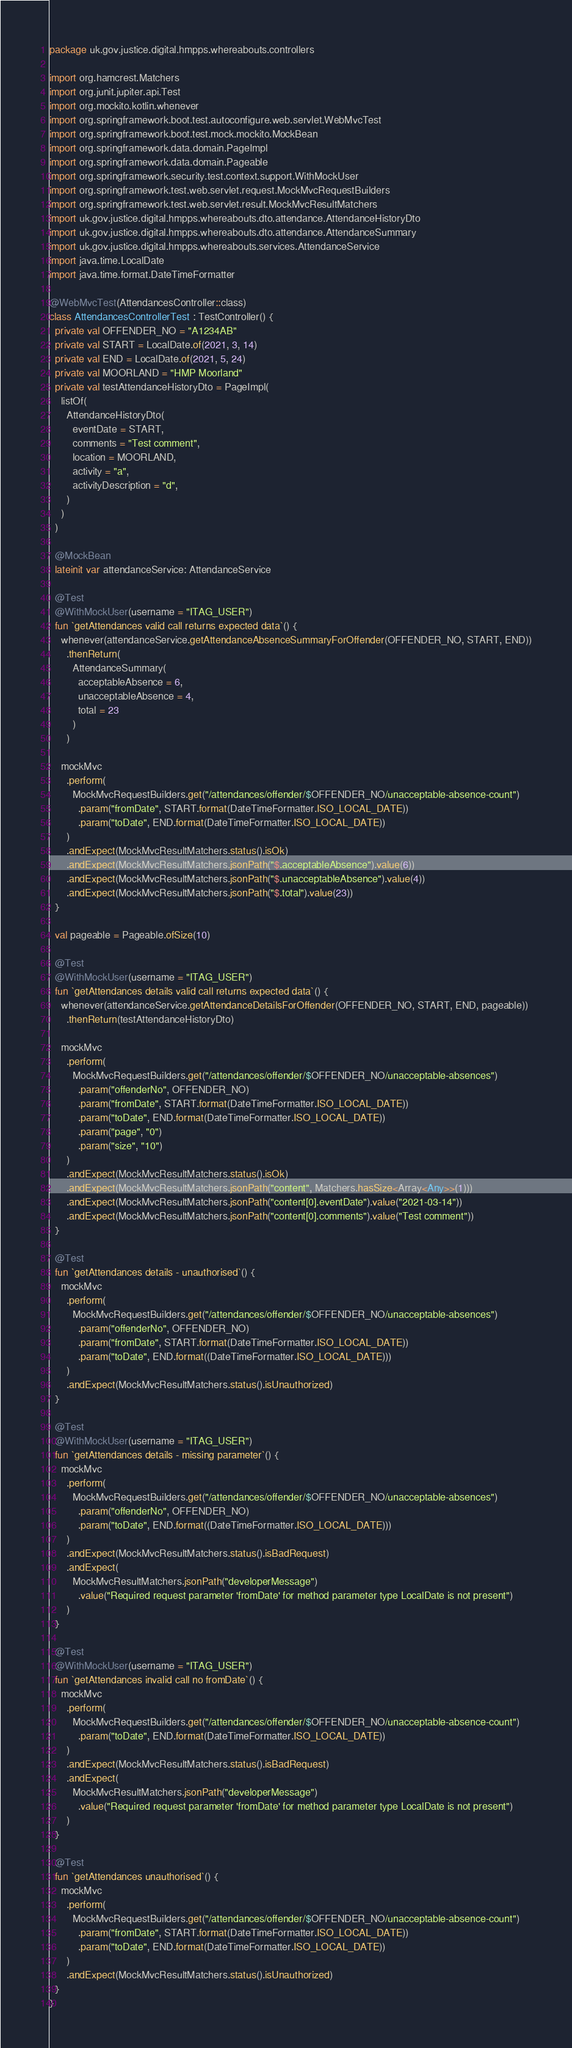<code> <loc_0><loc_0><loc_500><loc_500><_Kotlin_>package uk.gov.justice.digital.hmpps.whereabouts.controllers

import org.hamcrest.Matchers
import org.junit.jupiter.api.Test
import org.mockito.kotlin.whenever
import org.springframework.boot.test.autoconfigure.web.servlet.WebMvcTest
import org.springframework.boot.test.mock.mockito.MockBean
import org.springframework.data.domain.PageImpl
import org.springframework.data.domain.Pageable
import org.springframework.security.test.context.support.WithMockUser
import org.springframework.test.web.servlet.request.MockMvcRequestBuilders
import org.springframework.test.web.servlet.result.MockMvcResultMatchers
import uk.gov.justice.digital.hmpps.whereabouts.dto.attendance.AttendanceHistoryDto
import uk.gov.justice.digital.hmpps.whereabouts.dto.attendance.AttendanceSummary
import uk.gov.justice.digital.hmpps.whereabouts.services.AttendanceService
import java.time.LocalDate
import java.time.format.DateTimeFormatter

@WebMvcTest(AttendancesController::class)
class AttendancesControllerTest : TestController() {
  private val OFFENDER_NO = "A1234AB"
  private val START = LocalDate.of(2021, 3, 14)
  private val END = LocalDate.of(2021, 5, 24)
  private val MOORLAND = "HMP Moorland"
  private val testAttendanceHistoryDto = PageImpl(
    listOf(
      AttendanceHistoryDto(
        eventDate = START,
        comments = "Test comment",
        location = MOORLAND,
        activity = "a",
        activityDescription = "d",
      )
    )
  )

  @MockBean
  lateinit var attendanceService: AttendanceService

  @Test
  @WithMockUser(username = "ITAG_USER")
  fun `getAttendances valid call returns expected data`() {
    whenever(attendanceService.getAttendanceAbsenceSummaryForOffender(OFFENDER_NO, START, END))
      .thenReturn(
        AttendanceSummary(
          acceptableAbsence = 6,
          unacceptableAbsence = 4,
          total = 23
        )
      )

    mockMvc
      .perform(
        MockMvcRequestBuilders.get("/attendances/offender/$OFFENDER_NO/unacceptable-absence-count")
          .param("fromDate", START.format(DateTimeFormatter.ISO_LOCAL_DATE))
          .param("toDate", END.format(DateTimeFormatter.ISO_LOCAL_DATE))
      )
      .andExpect(MockMvcResultMatchers.status().isOk)
      .andExpect(MockMvcResultMatchers.jsonPath("$.acceptableAbsence").value(6))
      .andExpect(MockMvcResultMatchers.jsonPath("$.unacceptableAbsence").value(4))
      .andExpect(MockMvcResultMatchers.jsonPath("$.total").value(23))
  }

  val pageable = Pageable.ofSize(10)

  @Test
  @WithMockUser(username = "ITAG_USER")
  fun `getAttendances details valid call returns expected data`() {
    whenever(attendanceService.getAttendanceDetailsForOffender(OFFENDER_NO, START, END, pageable))
      .thenReturn(testAttendanceHistoryDto)

    mockMvc
      .perform(
        MockMvcRequestBuilders.get("/attendances/offender/$OFFENDER_NO/unacceptable-absences")
          .param("offenderNo", OFFENDER_NO)
          .param("fromDate", START.format(DateTimeFormatter.ISO_LOCAL_DATE))
          .param("toDate", END.format(DateTimeFormatter.ISO_LOCAL_DATE))
          .param("page", "0")
          .param("size", "10")
      )
      .andExpect(MockMvcResultMatchers.status().isOk)
      .andExpect(MockMvcResultMatchers.jsonPath("content", Matchers.hasSize<Array<Any>>(1)))
      .andExpect(MockMvcResultMatchers.jsonPath("content[0].eventDate").value("2021-03-14"))
      .andExpect(MockMvcResultMatchers.jsonPath("content[0].comments").value("Test comment"))
  }

  @Test
  fun `getAttendances details - unauthorised`() {
    mockMvc
      .perform(
        MockMvcRequestBuilders.get("/attendances/offender/$OFFENDER_NO/unacceptable-absences")
          .param("offenderNo", OFFENDER_NO)
          .param("fromDate", START.format(DateTimeFormatter.ISO_LOCAL_DATE))
          .param("toDate", END.format((DateTimeFormatter.ISO_LOCAL_DATE)))
      )
      .andExpect(MockMvcResultMatchers.status().isUnauthorized)
  }

  @Test
  @WithMockUser(username = "ITAG_USER")
  fun `getAttendances details - missing parameter`() {
    mockMvc
      .perform(
        MockMvcRequestBuilders.get("/attendances/offender/$OFFENDER_NO/unacceptable-absences")
          .param("offenderNo", OFFENDER_NO)
          .param("toDate", END.format((DateTimeFormatter.ISO_LOCAL_DATE)))
      )
      .andExpect(MockMvcResultMatchers.status().isBadRequest)
      .andExpect(
        MockMvcResultMatchers.jsonPath("developerMessage")
          .value("Required request parameter 'fromDate' for method parameter type LocalDate is not present")
      )
  }

  @Test
  @WithMockUser(username = "ITAG_USER")
  fun `getAttendances invalid call no fromDate`() {
    mockMvc
      .perform(
        MockMvcRequestBuilders.get("/attendances/offender/$OFFENDER_NO/unacceptable-absence-count")
          .param("toDate", END.format(DateTimeFormatter.ISO_LOCAL_DATE))
      )
      .andExpect(MockMvcResultMatchers.status().isBadRequest)
      .andExpect(
        MockMvcResultMatchers.jsonPath("developerMessage")
          .value("Required request parameter 'fromDate' for method parameter type LocalDate is not present")
      )
  }

  @Test
  fun `getAttendances unauthorised`() {
    mockMvc
      .perform(
        MockMvcRequestBuilders.get("/attendances/offender/$OFFENDER_NO/unacceptable-absence-count")
          .param("fromDate", START.format(DateTimeFormatter.ISO_LOCAL_DATE))
          .param("toDate", END.format(DateTimeFormatter.ISO_LOCAL_DATE))
      )
      .andExpect(MockMvcResultMatchers.status().isUnauthorized)
  }
}
</code> 